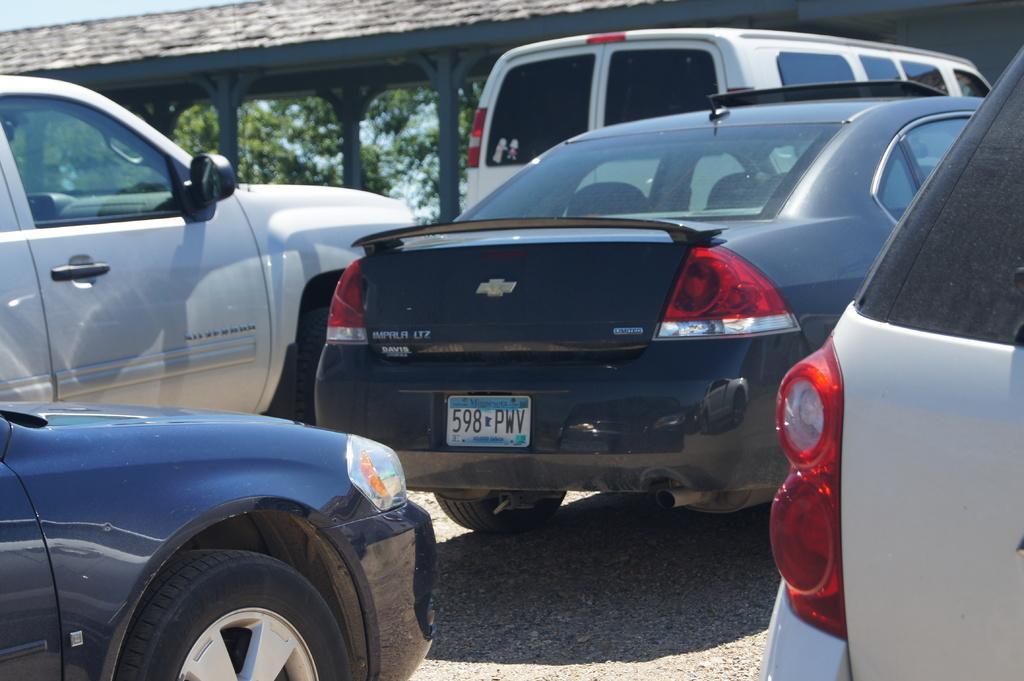How would you summarize this image in a sentence or two? In this image there is a black car in the middle and there are cars around it. In the background there is a building. Behind the building there are trees. 